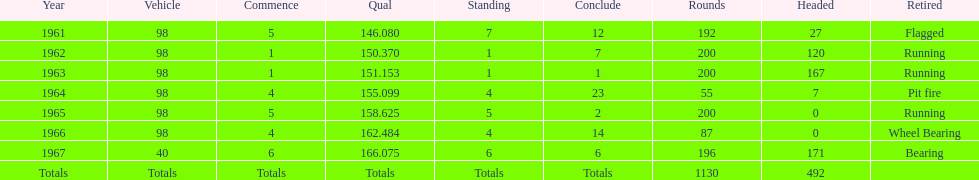What car achieved the highest qual? 40. 